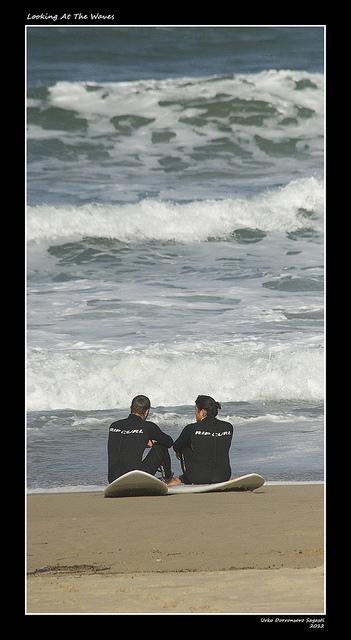Are these ideal conditions for surfing?
Be succinct. Yes. How many white caps are in the ocean?
Quick response, please. 3. How many men are there?
Give a very brief answer. 2. 